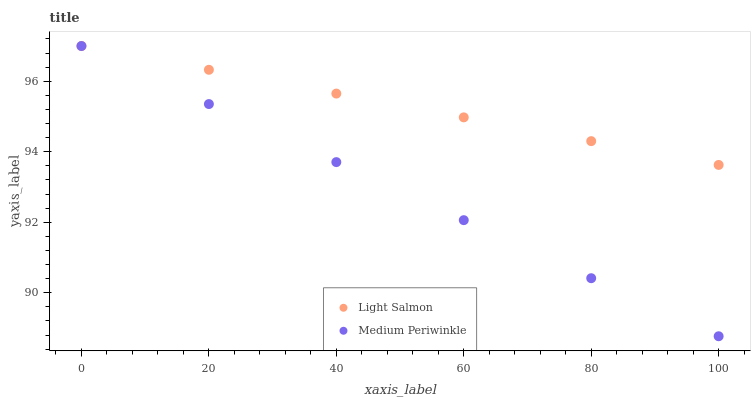Does Medium Periwinkle have the minimum area under the curve?
Answer yes or no. Yes. Does Light Salmon have the maximum area under the curve?
Answer yes or no. Yes. Does Medium Periwinkle have the maximum area under the curve?
Answer yes or no. No. Is Medium Periwinkle the smoothest?
Answer yes or no. Yes. Is Light Salmon the roughest?
Answer yes or no. Yes. Is Medium Periwinkle the roughest?
Answer yes or no. No. Does Medium Periwinkle have the lowest value?
Answer yes or no. Yes. Does Medium Periwinkle have the highest value?
Answer yes or no. Yes. Does Medium Periwinkle intersect Light Salmon?
Answer yes or no. Yes. Is Medium Periwinkle less than Light Salmon?
Answer yes or no. No. Is Medium Periwinkle greater than Light Salmon?
Answer yes or no. No. 